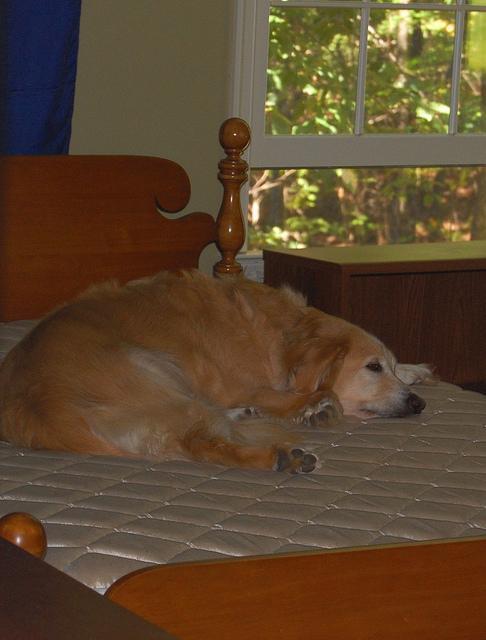How many dogs are there?
Give a very brief answer. 1. How many windows on this airplane are touched by red or orange paint?
Give a very brief answer. 0. 